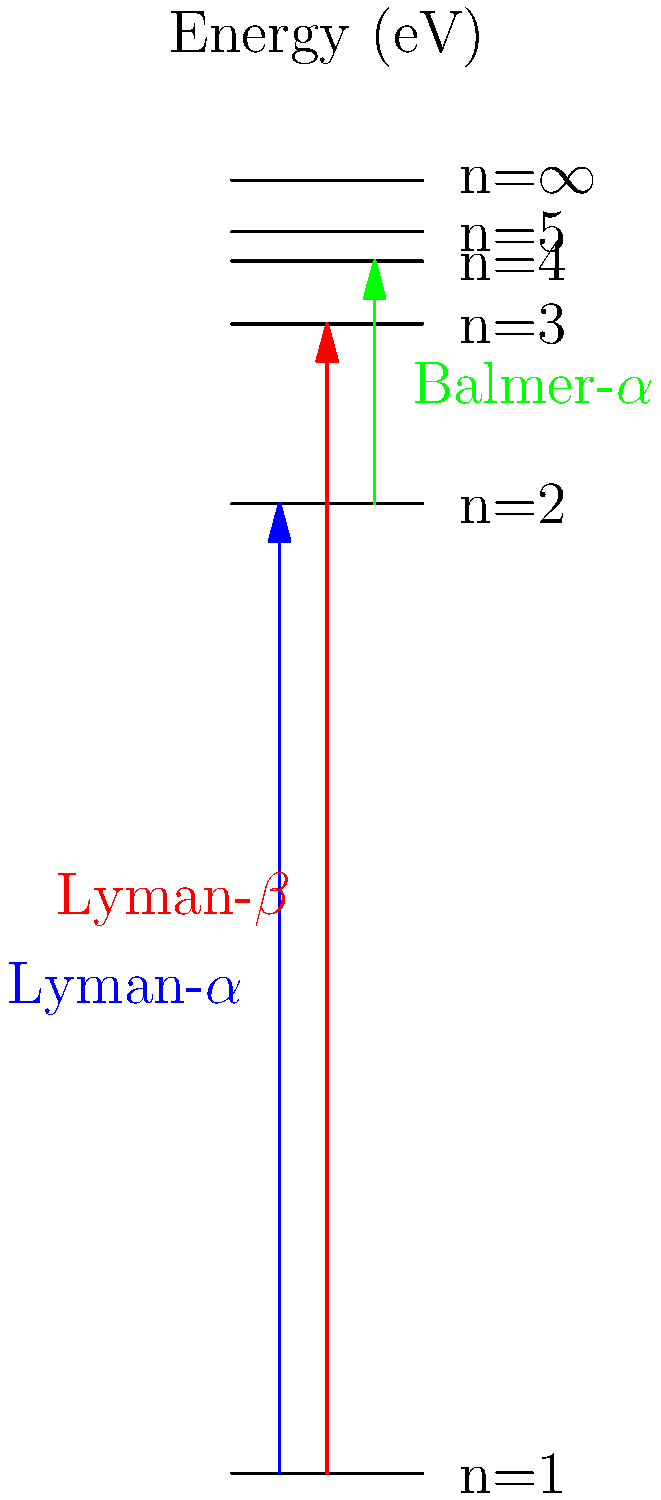Given the energy level diagram for a hydrogen atom, calculate the wavelength of the Lyman-$\alpha$ transition in nanometers. Use the Planck-Einstein relation $E = hf = \frac{hc}{\lambda}$, where $h = 6.626 \times 10^{-34}$ J⋅s and $c = 2.998 \times 10^8$ m/s. To calculate the wavelength of the Lyman-$\alpha$ transition, we'll follow these steps:

1. Identify the energy difference for the Lyman-$\alpha$ transition:
   $\Delta E = E_{n=2} - E_{n=1} = -3.4 \text{ eV} - (-13.6 \text{ eV}) = 10.2 \text{ eV}$

2. Convert the energy difference from eV to Joules:
   $\Delta E = 10.2 \text{ eV} \times 1.602 \times 10^{-19} \text{ J/eV} = 1.634 \times 10^{-18} \text{ J}$

3. Use the Planck-Einstein relation to solve for wavelength:
   $E = \frac{hc}{\lambda}$
   $\lambda = \frac{hc}{E}$

4. Substitute the values:
   $\lambda = \frac{(6.626 \times 10^{-34} \text{ J⋅s})(2.998 \times 10^8 \text{ m/s})}{1.634 \times 10^{-18} \text{ J}}$

5. Calculate the result:
   $\lambda = 1.216 \times 10^{-7} \text{ m}$

6. Convert to nanometers:
   $\lambda = 1.216 \times 10^{-7} \text{ m} \times \frac{10^9 \text{ nm}}{1 \text{ m}} = 121.6 \text{ nm}$
Answer: 121.6 nm 